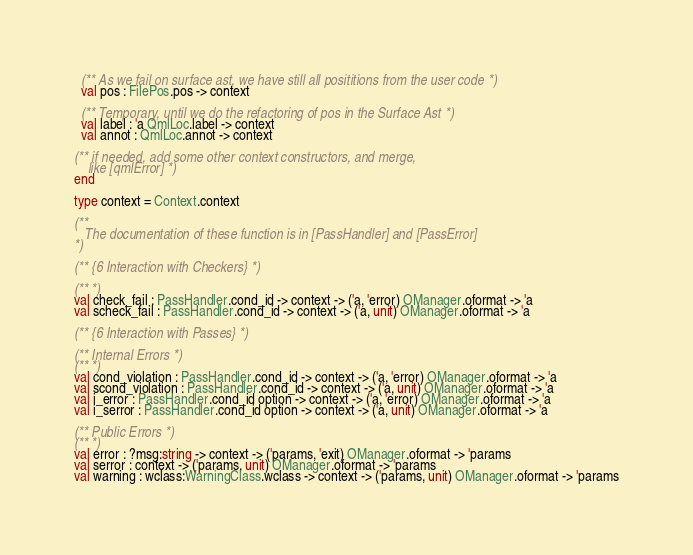Convert code to text. <code><loc_0><loc_0><loc_500><loc_500><_OCaml_>
  (** As we fail on surface ast, we have still all posititions from the user code *)
  val pos : FilePos.pos -> context

  (** Temporary, until we do the refactoring of pos in the Surface Ast *)
  val label : 'a QmlLoc.label -> context
  val annot : QmlLoc.annot -> context

(** if needed, add some other context constructors, and merge,
    like [qmlError] *)
end

type context = Context.context

(**
   The documentation of these function is in [PassHandler] and [PassError]
*)

(** {6 Interaction with Checkers} *)

(** *)
val check_fail : PassHandler.cond_id -> context -> ('a, 'error) OManager.oformat -> 'a
val scheck_fail : PassHandler.cond_id -> context -> ('a, unit) OManager.oformat -> 'a

(** {6 Interaction with Passes} *)

(** Internal Errors *)
(** *)
val cond_violation : PassHandler.cond_id -> context -> ('a, 'error) OManager.oformat -> 'a
val scond_violation : PassHandler.cond_id -> context -> ('a, unit) OManager.oformat -> 'a
val i_error : PassHandler.cond_id option -> context -> ('a, 'error) OManager.oformat -> 'a
val i_serror : PassHandler.cond_id option -> context -> ('a, unit) OManager.oformat -> 'a

(** Public Errors *)
(** *)
val error : ?msg:string -> context -> ('params, 'exit) OManager.oformat -> 'params
val serror : context -> ('params, unit) OManager.oformat -> 'params
val warning : wclass:WarningClass.wclass -> context -> ('params, unit) OManager.oformat -> 'params
</code> 